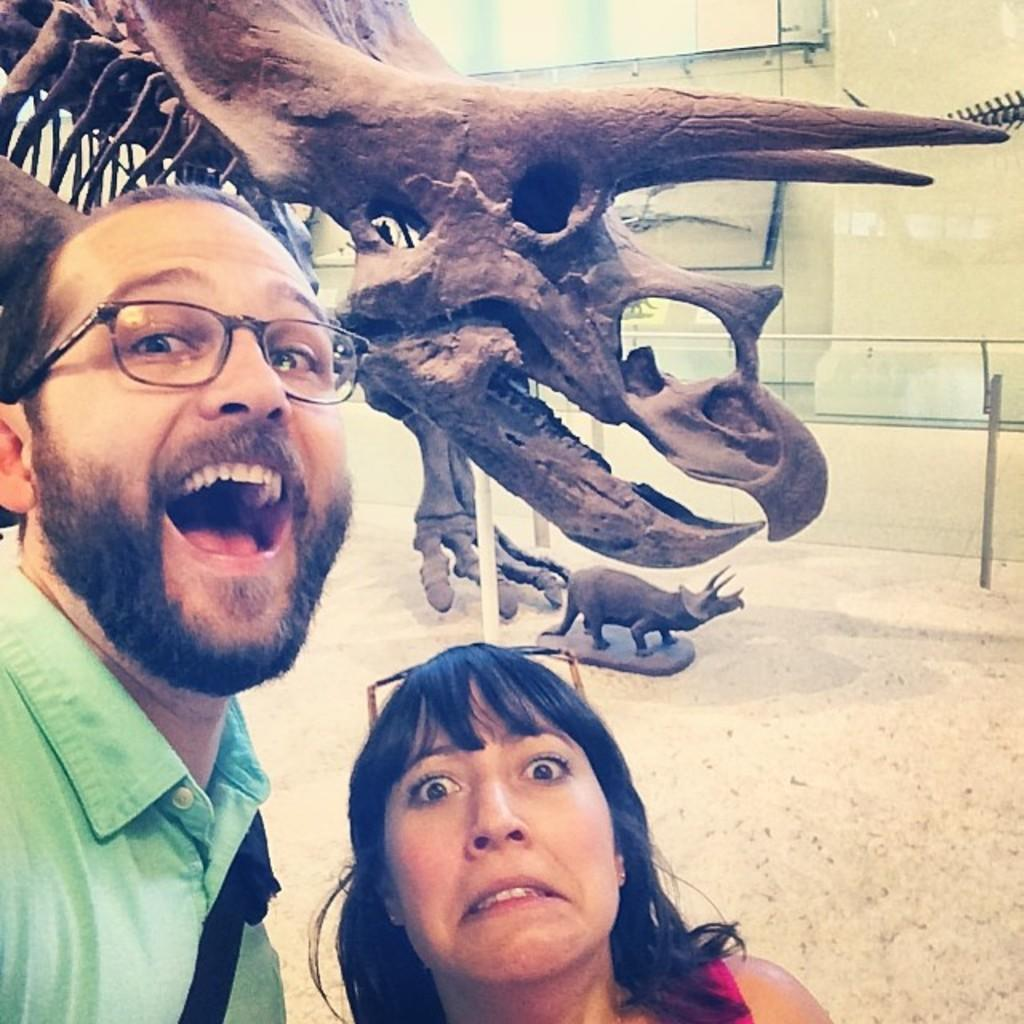How many people are in the image? There are two persons in the image. What are they standing in front of? They are in front of a dinosaur fossil. Can you describe the position of the person on the left side of the image? The person on the left side of the image is wearing clothes and spectacles. What type of drum is the beginner playing in the image? There is no drum or beginner present in the image; it features two people in front of a dinosaur fossil. 